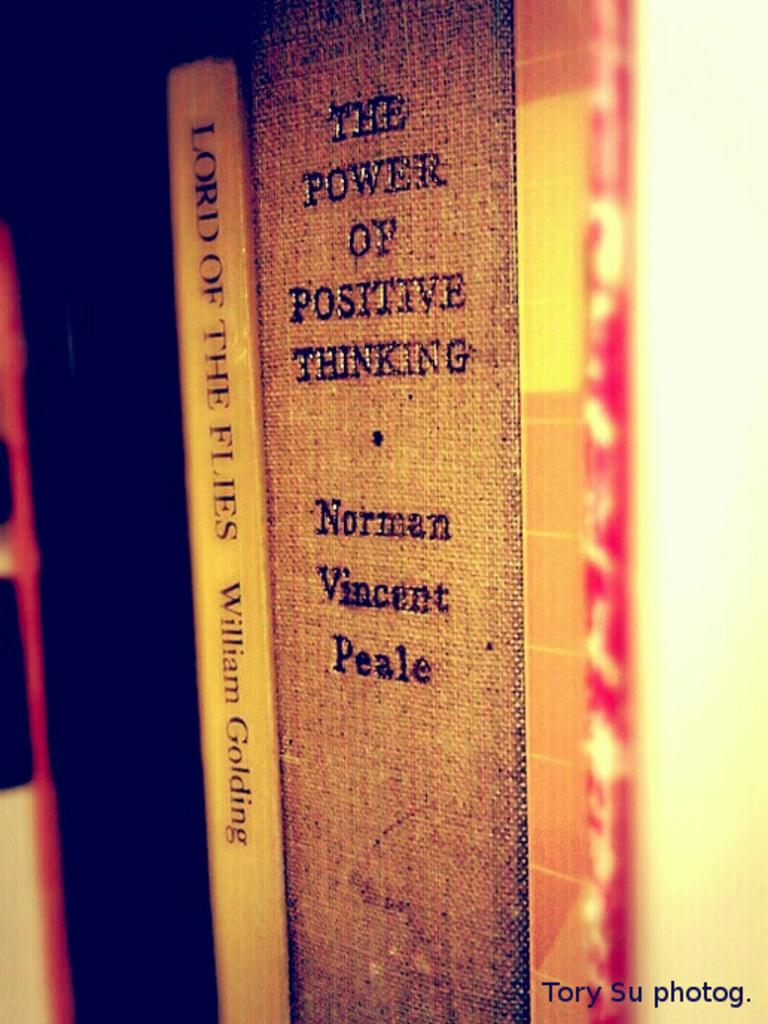<image>
Relay a brief, clear account of the picture shown. Norman Vincent Peale's book sits on a shelf with some other books. 